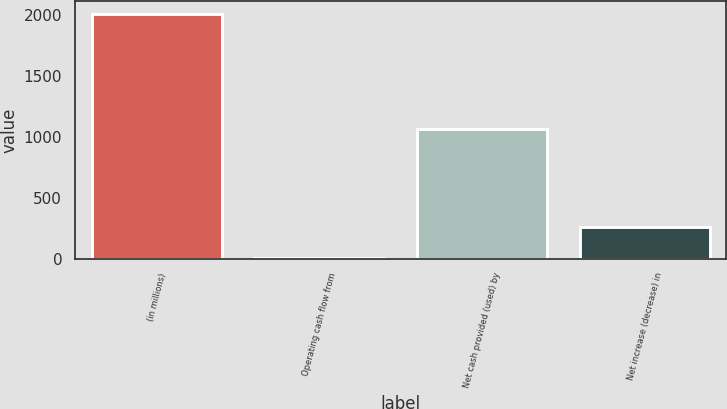Convert chart. <chart><loc_0><loc_0><loc_500><loc_500><bar_chart><fcel>(in millions)<fcel>Operating cash flow from<fcel>Net cash provided (used) by<fcel>Net increase (decrease) in<nl><fcel>2011<fcel>3<fcel>1065.2<fcel>262<nl></chart> 